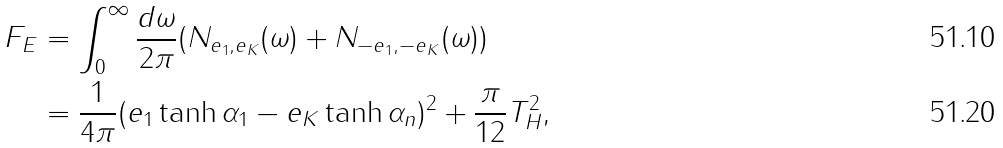<formula> <loc_0><loc_0><loc_500><loc_500>F _ { E } & = \int ^ { \infty } _ { 0 } \frac { d \omega } { 2 \pi } ( N _ { e _ { 1 } , e _ { K } } ( \omega ) + N _ { - e _ { 1 } , - e _ { K } } ( \omega ) ) \\ & = \frac { 1 } { 4 \pi } ( e _ { 1 } \tanh \alpha _ { 1 } - e _ { K } \tanh \alpha _ { n } ) ^ { 2 } + \frac { \pi } { 1 2 } T _ { H } ^ { 2 } ,</formula> 